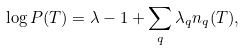Convert formula to latex. <formula><loc_0><loc_0><loc_500><loc_500>\log P ( T ) = \lambda - 1 + \sum _ { q } \lambda _ { q } n _ { q } ( T ) ,</formula> 